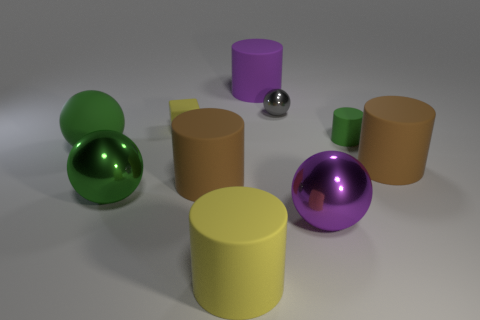What could be the purpose of this arrangement of objects? The arrangement could be part of a visual study of shapes, textures, and colors, perhaps used in a 3D modeling software tutorial or as an artistic composition exploring geometric forms. 